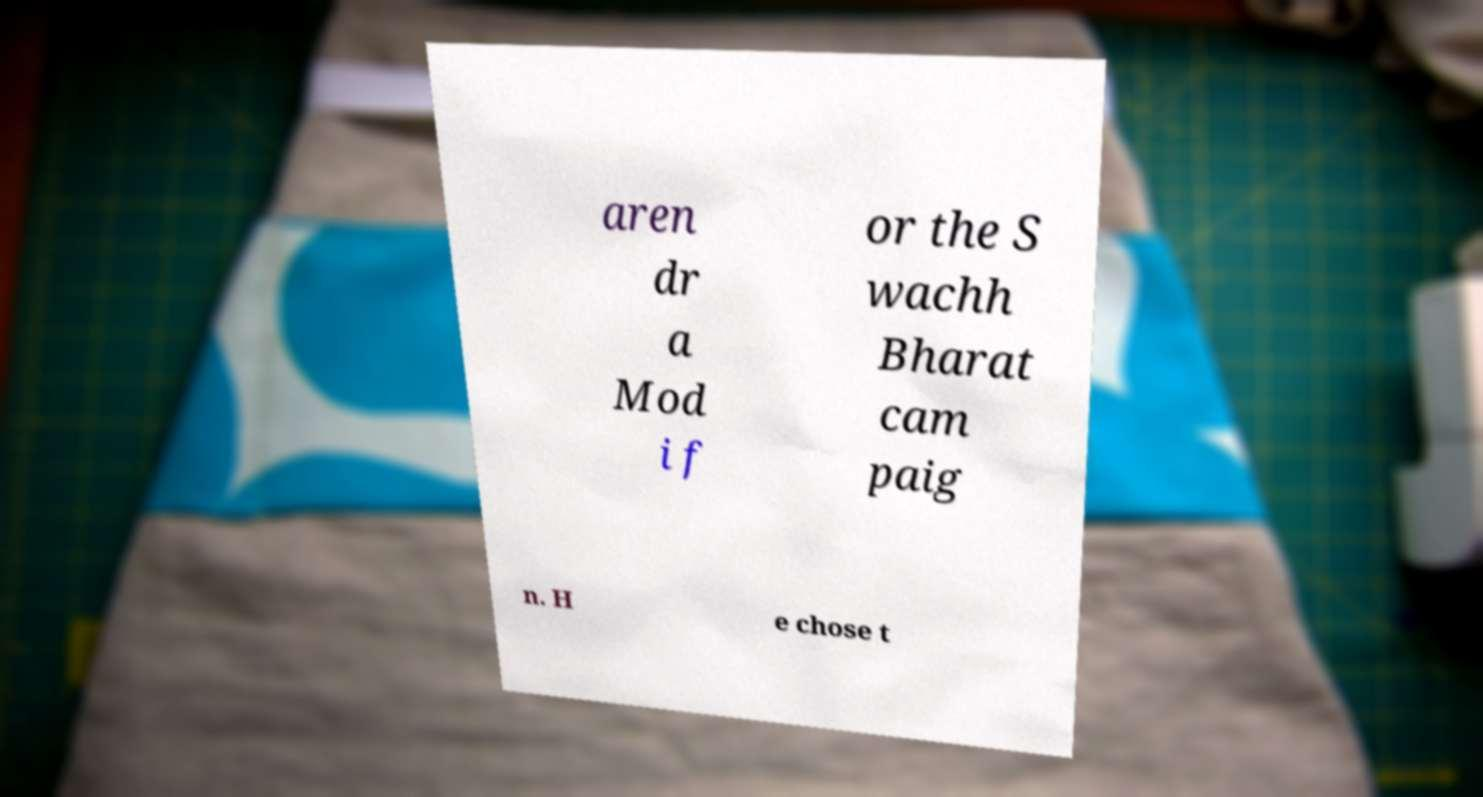I need the written content from this picture converted into text. Can you do that? aren dr a Mod i f or the S wachh Bharat cam paig n. H e chose t 